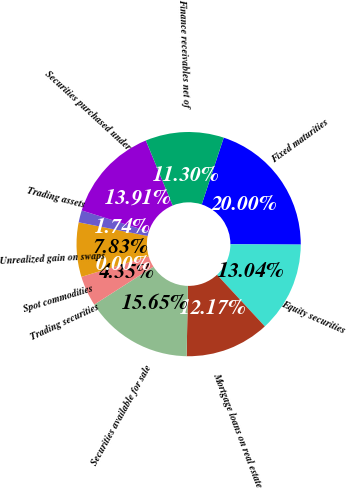Convert chart to OTSL. <chart><loc_0><loc_0><loc_500><loc_500><pie_chart><fcel>Fixed maturities<fcel>Equity securities<fcel>Mortgage loans on real estate<fcel>Securities available for sale<fcel>Trading securities<fcel>Spot commodities<fcel>Unrealized gain on swaps<fcel>Trading assets<fcel>Securities purchased under<fcel>Finance receivables net of<nl><fcel>20.0%<fcel>13.04%<fcel>12.17%<fcel>15.65%<fcel>4.35%<fcel>0.0%<fcel>7.83%<fcel>1.74%<fcel>13.91%<fcel>11.3%<nl></chart> 